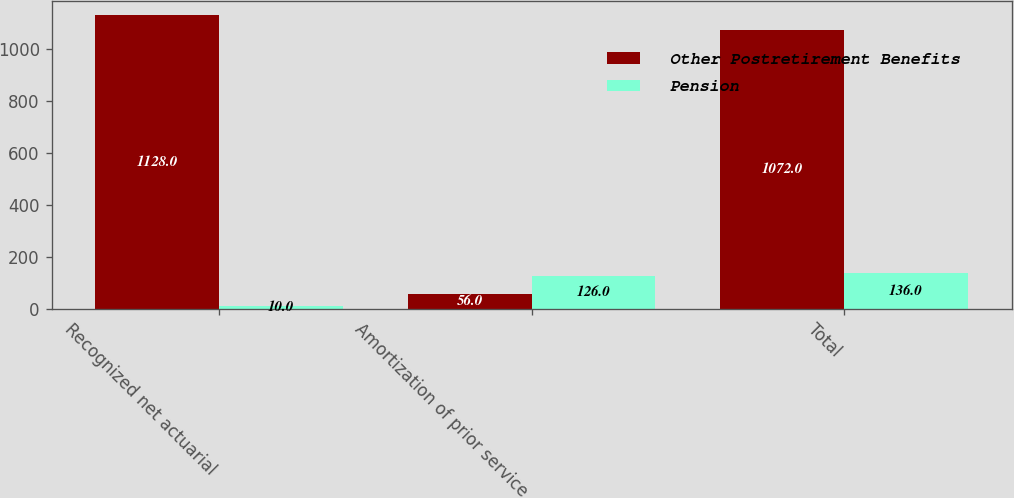<chart> <loc_0><loc_0><loc_500><loc_500><stacked_bar_chart><ecel><fcel>Recognized net actuarial<fcel>Amortization of prior service<fcel>Total<nl><fcel>Other Postretirement Benefits<fcel>1128<fcel>56<fcel>1072<nl><fcel>Pension<fcel>10<fcel>126<fcel>136<nl></chart> 